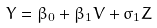Convert formula to latex. <formula><loc_0><loc_0><loc_500><loc_500>Y = \beta _ { 0 } + \beta _ { 1 } V + \sigma _ { 1 } Z</formula> 